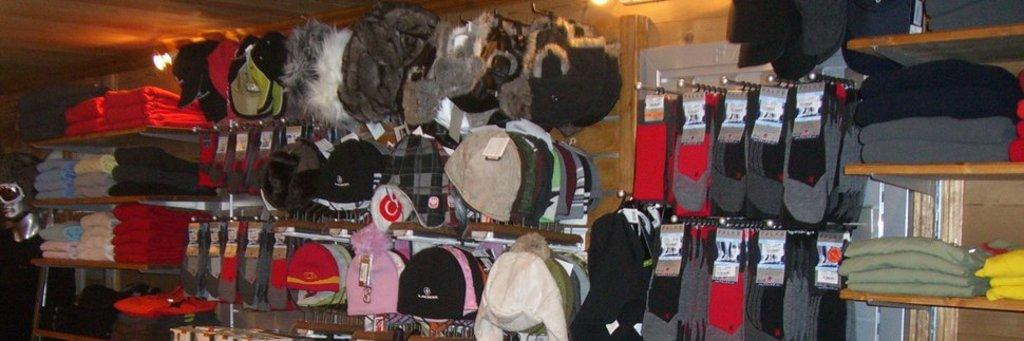What type of accessories are visible in the image? There are caps in the image. What other clothing items can be seen in the image? There are clothes and socks visible in the image. How are the items arranged in the image? The items are arranged in rows. What can be seen in the background of the image? There is a light and a wall in the background of the image. Can you hear the land laughing in the image? There is no land or laughter present in the image; it only features caps, clothes, socks, and the background elements. 